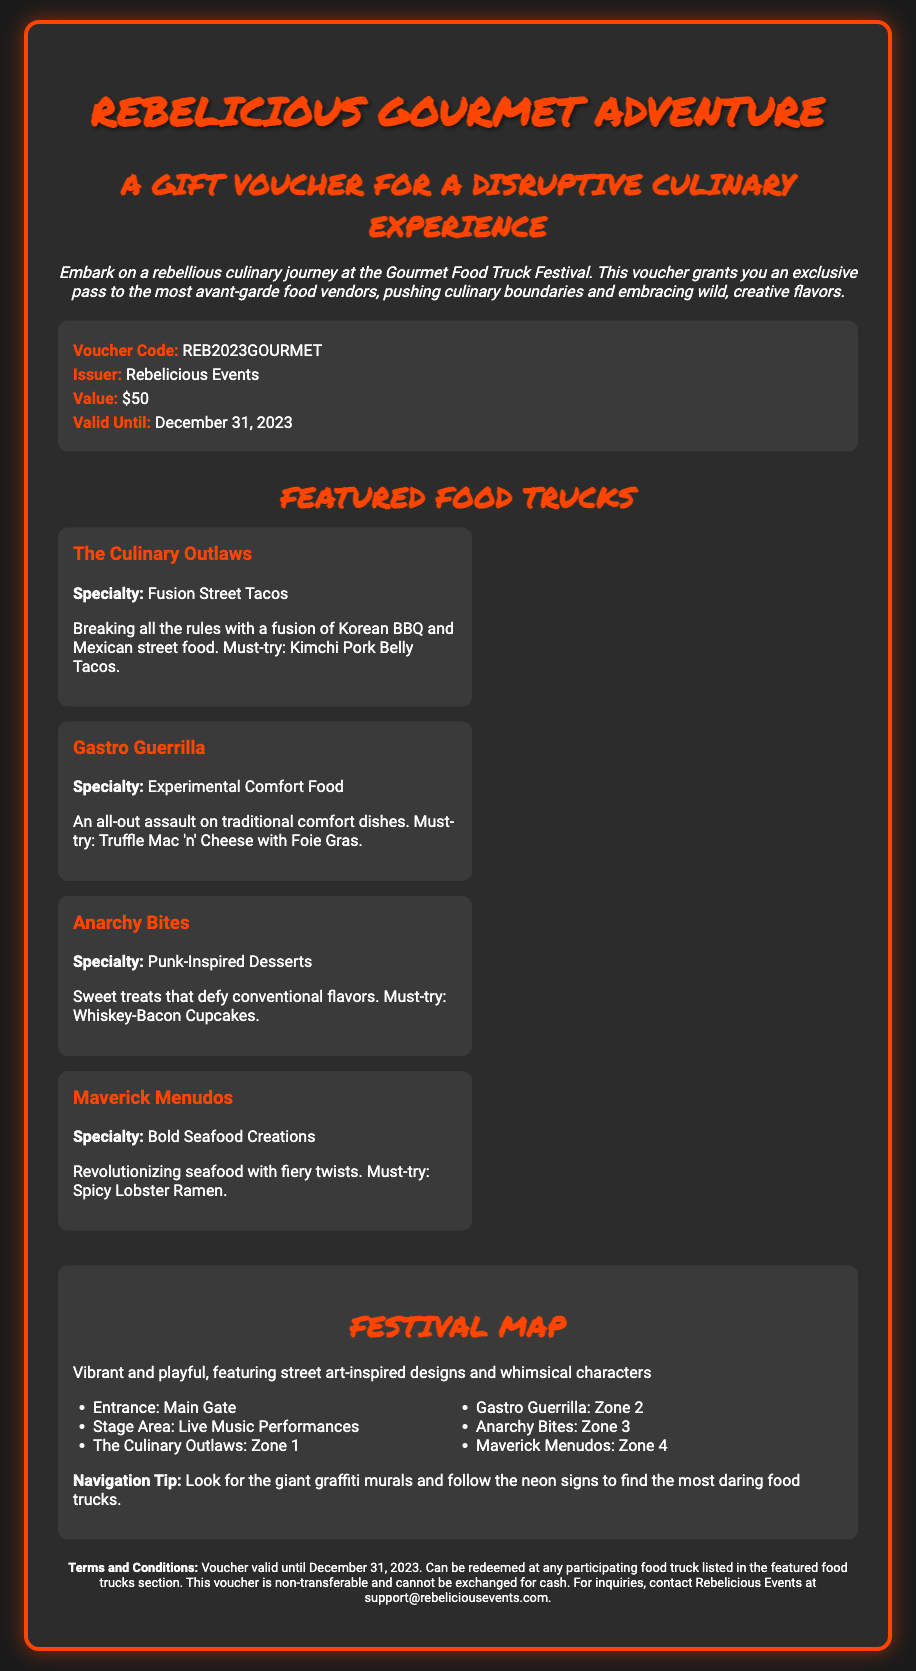What is the name of the gift voucher? The title of the gift voucher is clearly stated at the top of the document, which is "Rebelicious Gourmet Adventure."
Answer: Rebelicious Gourmet Adventure Who is the issuer of the voucher? The issuer's name is listed in the voucher details section of the document, identifying who is providing the gift voucher.
Answer: Rebelicious Events What is the value of the gift voucher? The voucher details explicitly mention the amount assigned to the voucher, indicating how much it is worth for redemption.
Answer: $50 Until what date is the voucher valid? The validity period of the voucher is specified in the voucher details, providing the expiration date for the use of the gift voucher.
Answer: December 31, 2023 What is the specialty of "Gastro Guerrilla"? The details of each featured food truck, including their specialties, are provided in the document, indicating what each vendor offers.
Answer: Experimental Comfort Food 